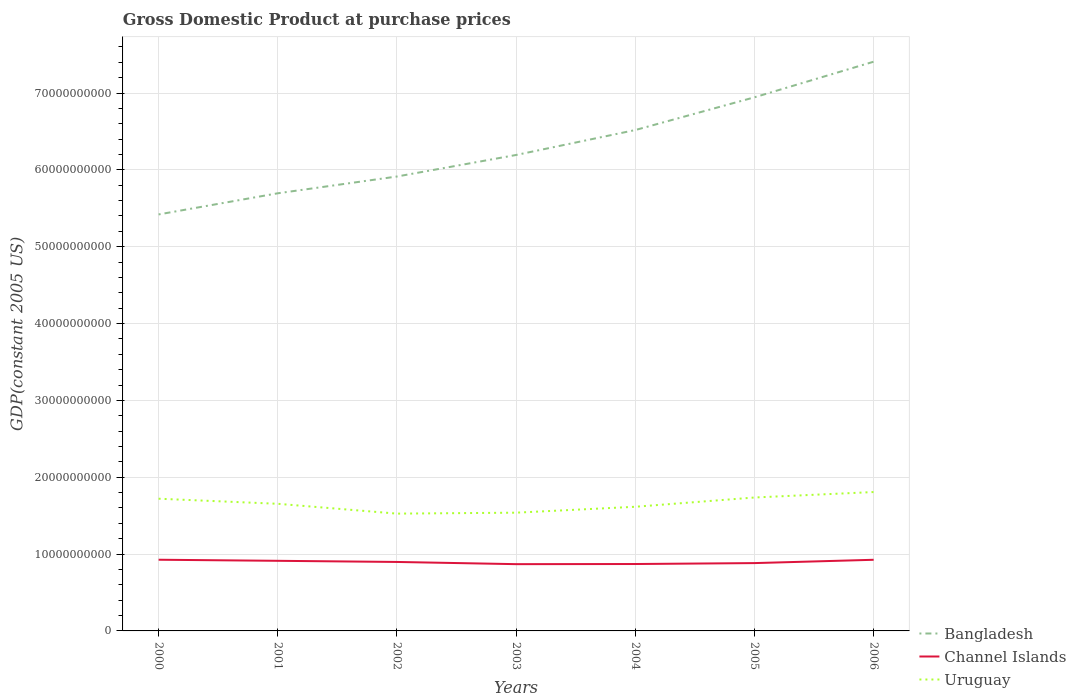Does the line corresponding to Channel Islands intersect with the line corresponding to Bangladesh?
Provide a succinct answer. No. Is the number of lines equal to the number of legend labels?
Your response must be concise. Yes. Across all years, what is the maximum GDP at purchase prices in Channel Islands?
Offer a very short reply. 8.69e+09. What is the total GDP at purchase prices in Channel Islands in the graph?
Give a very brief answer. 6.08e+06. What is the difference between the highest and the second highest GDP at purchase prices in Uruguay?
Make the answer very short. 2.81e+09. What is the difference between the highest and the lowest GDP at purchase prices in Channel Islands?
Give a very brief answer. 3. How many lines are there?
Provide a succinct answer. 3. How many years are there in the graph?
Offer a terse response. 7. Are the values on the major ticks of Y-axis written in scientific E-notation?
Provide a short and direct response. No. Does the graph contain any zero values?
Make the answer very short. No. Does the graph contain grids?
Keep it short and to the point. Yes. Where does the legend appear in the graph?
Provide a short and direct response. Bottom right. How many legend labels are there?
Provide a short and direct response. 3. How are the legend labels stacked?
Provide a short and direct response. Vertical. What is the title of the graph?
Your answer should be compact. Gross Domestic Product at purchase prices. Does "French Polynesia" appear as one of the legend labels in the graph?
Give a very brief answer. No. What is the label or title of the X-axis?
Keep it short and to the point. Years. What is the label or title of the Y-axis?
Provide a short and direct response. GDP(constant 2005 US). What is the GDP(constant 2005 US) of Bangladesh in 2000?
Provide a short and direct response. 5.42e+1. What is the GDP(constant 2005 US) in Channel Islands in 2000?
Your answer should be compact. 9.26e+09. What is the GDP(constant 2005 US) in Uruguay in 2000?
Your answer should be very brief. 1.72e+1. What is the GDP(constant 2005 US) of Bangladesh in 2001?
Keep it short and to the point. 5.70e+1. What is the GDP(constant 2005 US) of Channel Islands in 2001?
Provide a succinct answer. 9.12e+09. What is the GDP(constant 2005 US) in Uruguay in 2001?
Offer a terse response. 1.65e+1. What is the GDP(constant 2005 US) of Bangladesh in 2002?
Offer a terse response. 5.91e+1. What is the GDP(constant 2005 US) in Channel Islands in 2002?
Make the answer very short. 8.98e+09. What is the GDP(constant 2005 US) in Uruguay in 2002?
Keep it short and to the point. 1.53e+1. What is the GDP(constant 2005 US) of Bangladesh in 2003?
Your response must be concise. 6.19e+1. What is the GDP(constant 2005 US) of Channel Islands in 2003?
Give a very brief answer. 8.69e+09. What is the GDP(constant 2005 US) of Uruguay in 2003?
Provide a short and direct response. 1.54e+1. What is the GDP(constant 2005 US) of Bangladesh in 2004?
Keep it short and to the point. 6.52e+1. What is the GDP(constant 2005 US) of Channel Islands in 2004?
Give a very brief answer. 8.71e+09. What is the GDP(constant 2005 US) of Uruguay in 2004?
Your answer should be very brief. 1.62e+1. What is the GDP(constant 2005 US) in Bangladesh in 2005?
Ensure brevity in your answer.  6.94e+1. What is the GDP(constant 2005 US) in Channel Islands in 2005?
Make the answer very short. 8.83e+09. What is the GDP(constant 2005 US) in Uruguay in 2005?
Offer a terse response. 1.74e+1. What is the GDP(constant 2005 US) of Bangladesh in 2006?
Offer a terse response. 7.41e+1. What is the GDP(constant 2005 US) of Channel Islands in 2006?
Offer a terse response. 9.26e+09. What is the GDP(constant 2005 US) in Uruguay in 2006?
Your answer should be compact. 1.81e+1. Across all years, what is the maximum GDP(constant 2005 US) of Bangladesh?
Give a very brief answer. 7.41e+1. Across all years, what is the maximum GDP(constant 2005 US) in Channel Islands?
Ensure brevity in your answer.  9.26e+09. Across all years, what is the maximum GDP(constant 2005 US) of Uruguay?
Ensure brevity in your answer.  1.81e+1. Across all years, what is the minimum GDP(constant 2005 US) of Bangladesh?
Offer a very short reply. 5.42e+1. Across all years, what is the minimum GDP(constant 2005 US) in Channel Islands?
Your response must be concise. 8.69e+09. Across all years, what is the minimum GDP(constant 2005 US) of Uruguay?
Provide a succinct answer. 1.53e+1. What is the total GDP(constant 2005 US) of Bangladesh in the graph?
Offer a terse response. 4.41e+11. What is the total GDP(constant 2005 US) in Channel Islands in the graph?
Your answer should be compact. 6.28e+1. What is the total GDP(constant 2005 US) in Uruguay in the graph?
Your response must be concise. 1.16e+11. What is the difference between the GDP(constant 2005 US) in Bangladesh in 2000 and that in 2001?
Provide a succinct answer. -2.75e+09. What is the difference between the GDP(constant 2005 US) in Channel Islands in 2000 and that in 2001?
Provide a succinct answer. 1.40e+08. What is the difference between the GDP(constant 2005 US) of Uruguay in 2000 and that in 2001?
Provide a short and direct response. 6.61e+08. What is the difference between the GDP(constant 2005 US) of Bangladesh in 2000 and that in 2002?
Your answer should be very brief. -4.93e+09. What is the difference between the GDP(constant 2005 US) of Channel Islands in 2000 and that in 2002?
Offer a very short reply. 2.89e+08. What is the difference between the GDP(constant 2005 US) in Uruguay in 2000 and that in 2002?
Provide a short and direct response. 1.94e+09. What is the difference between the GDP(constant 2005 US) in Bangladesh in 2000 and that in 2003?
Your response must be concise. -7.74e+09. What is the difference between the GDP(constant 2005 US) of Channel Islands in 2000 and that in 2003?
Offer a very short reply. 5.76e+08. What is the difference between the GDP(constant 2005 US) of Uruguay in 2000 and that in 2003?
Provide a short and direct response. 1.82e+09. What is the difference between the GDP(constant 2005 US) in Bangladesh in 2000 and that in 2004?
Keep it short and to the point. -1.10e+1. What is the difference between the GDP(constant 2005 US) in Channel Islands in 2000 and that in 2004?
Give a very brief answer. 5.57e+08. What is the difference between the GDP(constant 2005 US) in Uruguay in 2000 and that in 2004?
Your response must be concise. 1.05e+09. What is the difference between the GDP(constant 2005 US) of Bangladesh in 2000 and that in 2005?
Keep it short and to the point. -1.52e+1. What is the difference between the GDP(constant 2005 US) of Channel Islands in 2000 and that in 2005?
Your response must be concise. 4.37e+08. What is the difference between the GDP(constant 2005 US) in Uruguay in 2000 and that in 2005?
Offer a very short reply. -1.58e+08. What is the difference between the GDP(constant 2005 US) of Bangladesh in 2000 and that in 2006?
Offer a terse response. -1.99e+1. What is the difference between the GDP(constant 2005 US) of Channel Islands in 2000 and that in 2006?
Give a very brief answer. 6.08e+06. What is the difference between the GDP(constant 2005 US) in Uruguay in 2000 and that in 2006?
Make the answer very short. -8.69e+08. What is the difference between the GDP(constant 2005 US) in Bangladesh in 2001 and that in 2002?
Offer a very short reply. -2.18e+09. What is the difference between the GDP(constant 2005 US) in Channel Islands in 2001 and that in 2002?
Your answer should be very brief. 1.49e+08. What is the difference between the GDP(constant 2005 US) in Uruguay in 2001 and that in 2002?
Provide a short and direct response. 1.28e+09. What is the difference between the GDP(constant 2005 US) in Bangladesh in 2001 and that in 2003?
Ensure brevity in your answer.  -4.99e+09. What is the difference between the GDP(constant 2005 US) of Channel Islands in 2001 and that in 2003?
Your response must be concise. 4.36e+08. What is the difference between the GDP(constant 2005 US) of Uruguay in 2001 and that in 2003?
Keep it short and to the point. 1.16e+09. What is the difference between the GDP(constant 2005 US) of Bangladesh in 2001 and that in 2004?
Make the answer very short. -8.23e+09. What is the difference between the GDP(constant 2005 US) of Channel Islands in 2001 and that in 2004?
Ensure brevity in your answer.  4.17e+08. What is the difference between the GDP(constant 2005 US) in Uruguay in 2001 and that in 2004?
Offer a terse response. 3.86e+08. What is the difference between the GDP(constant 2005 US) in Bangladesh in 2001 and that in 2005?
Make the answer very short. -1.25e+1. What is the difference between the GDP(constant 2005 US) in Channel Islands in 2001 and that in 2005?
Give a very brief answer. 2.97e+08. What is the difference between the GDP(constant 2005 US) in Uruguay in 2001 and that in 2005?
Give a very brief answer. -8.19e+08. What is the difference between the GDP(constant 2005 US) of Bangladesh in 2001 and that in 2006?
Offer a terse response. -1.71e+1. What is the difference between the GDP(constant 2005 US) of Channel Islands in 2001 and that in 2006?
Your answer should be compact. -1.34e+08. What is the difference between the GDP(constant 2005 US) of Uruguay in 2001 and that in 2006?
Ensure brevity in your answer.  -1.53e+09. What is the difference between the GDP(constant 2005 US) of Bangladesh in 2002 and that in 2003?
Provide a short and direct response. -2.80e+09. What is the difference between the GDP(constant 2005 US) of Channel Islands in 2002 and that in 2003?
Keep it short and to the point. 2.87e+08. What is the difference between the GDP(constant 2005 US) of Uruguay in 2002 and that in 2003?
Offer a terse response. -1.23e+08. What is the difference between the GDP(constant 2005 US) in Bangladesh in 2002 and that in 2004?
Provide a succinct answer. -6.05e+09. What is the difference between the GDP(constant 2005 US) in Channel Islands in 2002 and that in 2004?
Make the answer very short. 2.68e+08. What is the difference between the GDP(constant 2005 US) of Uruguay in 2002 and that in 2004?
Offer a very short reply. -8.93e+08. What is the difference between the GDP(constant 2005 US) of Bangladesh in 2002 and that in 2005?
Offer a terse response. -1.03e+1. What is the difference between the GDP(constant 2005 US) in Channel Islands in 2002 and that in 2005?
Provide a succinct answer. 1.48e+08. What is the difference between the GDP(constant 2005 US) of Uruguay in 2002 and that in 2005?
Offer a terse response. -2.10e+09. What is the difference between the GDP(constant 2005 US) of Bangladesh in 2002 and that in 2006?
Make the answer very short. -1.49e+1. What is the difference between the GDP(constant 2005 US) of Channel Islands in 2002 and that in 2006?
Provide a succinct answer. -2.83e+08. What is the difference between the GDP(constant 2005 US) of Uruguay in 2002 and that in 2006?
Offer a very short reply. -2.81e+09. What is the difference between the GDP(constant 2005 US) of Bangladesh in 2003 and that in 2004?
Your response must be concise. -3.25e+09. What is the difference between the GDP(constant 2005 US) of Channel Islands in 2003 and that in 2004?
Provide a short and direct response. -1.95e+07. What is the difference between the GDP(constant 2005 US) in Uruguay in 2003 and that in 2004?
Ensure brevity in your answer.  -7.70e+08. What is the difference between the GDP(constant 2005 US) of Bangladesh in 2003 and that in 2005?
Provide a succinct answer. -7.51e+09. What is the difference between the GDP(constant 2005 US) in Channel Islands in 2003 and that in 2005?
Give a very brief answer. -1.39e+08. What is the difference between the GDP(constant 2005 US) of Uruguay in 2003 and that in 2005?
Offer a very short reply. -1.98e+09. What is the difference between the GDP(constant 2005 US) of Bangladesh in 2003 and that in 2006?
Your response must be concise. -1.21e+1. What is the difference between the GDP(constant 2005 US) of Channel Islands in 2003 and that in 2006?
Offer a very short reply. -5.70e+08. What is the difference between the GDP(constant 2005 US) in Uruguay in 2003 and that in 2006?
Keep it short and to the point. -2.69e+09. What is the difference between the GDP(constant 2005 US) in Bangladesh in 2004 and that in 2005?
Ensure brevity in your answer.  -4.26e+09. What is the difference between the GDP(constant 2005 US) in Channel Islands in 2004 and that in 2005?
Your answer should be compact. -1.20e+08. What is the difference between the GDP(constant 2005 US) in Uruguay in 2004 and that in 2005?
Ensure brevity in your answer.  -1.21e+09. What is the difference between the GDP(constant 2005 US) in Bangladesh in 2004 and that in 2006?
Provide a succinct answer. -8.89e+09. What is the difference between the GDP(constant 2005 US) in Channel Islands in 2004 and that in 2006?
Offer a very short reply. -5.51e+08. What is the difference between the GDP(constant 2005 US) of Uruguay in 2004 and that in 2006?
Provide a succinct answer. -1.92e+09. What is the difference between the GDP(constant 2005 US) of Bangladesh in 2005 and that in 2006?
Offer a very short reply. -4.63e+09. What is the difference between the GDP(constant 2005 US) in Channel Islands in 2005 and that in 2006?
Provide a short and direct response. -4.31e+08. What is the difference between the GDP(constant 2005 US) in Uruguay in 2005 and that in 2006?
Make the answer very short. -7.12e+08. What is the difference between the GDP(constant 2005 US) of Bangladesh in 2000 and the GDP(constant 2005 US) of Channel Islands in 2001?
Keep it short and to the point. 4.51e+1. What is the difference between the GDP(constant 2005 US) of Bangladesh in 2000 and the GDP(constant 2005 US) of Uruguay in 2001?
Make the answer very short. 3.77e+1. What is the difference between the GDP(constant 2005 US) in Channel Islands in 2000 and the GDP(constant 2005 US) in Uruguay in 2001?
Provide a succinct answer. -7.28e+09. What is the difference between the GDP(constant 2005 US) in Bangladesh in 2000 and the GDP(constant 2005 US) in Channel Islands in 2002?
Provide a succinct answer. 4.52e+1. What is the difference between the GDP(constant 2005 US) in Bangladesh in 2000 and the GDP(constant 2005 US) in Uruguay in 2002?
Give a very brief answer. 3.89e+1. What is the difference between the GDP(constant 2005 US) of Channel Islands in 2000 and the GDP(constant 2005 US) of Uruguay in 2002?
Make the answer very short. -6.00e+09. What is the difference between the GDP(constant 2005 US) of Bangladesh in 2000 and the GDP(constant 2005 US) of Channel Islands in 2003?
Give a very brief answer. 4.55e+1. What is the difference between the GDP(constant 2005 US) in Bangladesh in 2000 and the GDP(constant 2005 US) in Uruguay in 2003?
Offer a very short reply. 3.88e+1. What is the difference between the GDP(constant 2005 US) in Channel Islands in 2000 and the GDP(constant 2005 US) in Uruguay in 2003?
Offer a terse response. -6.12e+09. What is the difference between the GDP(constant 2005 US) in Bangladesh in 2000 and the GDP(constant 2005 US) in Channel Islands in 2004?
Provide a succinct answer. 4.55e+1. What is the difference between the GDP(constant 2005 US) of Bangladesh in 2000 and the GDP(constant 2005 US) of Uruguay in 2004?
Provide a succinct answer. 3.80e+1. What is the difference between the GDP(constant 2005 US) of Channel Islands in 2000 and the GDP(constant 2005 US) of Uruguay in 2004?
Give a very brief answer. -6.89e+09. What is the difference between the GDP(constant 2005 US) in Bangladesh in 2000 and the GDP(constant 2005 US) in Channel Islands in 2005?
Give a very brief answer. 4.54e+1. What is the difference between the GDP(constant 2005 US) of Bangladesh in 2000 and the GDP(constant 2005 US) of Uruguay in 2005?
Your answer should be compact. 3.68e+1. What is the difference between the GDP(constant 2005 US) in Channel Islands in 2000 and the GDP(constant 2005 US) in Uruguay in 2005?
Ensure brevity in your answer.  -8.10e+09. What is the difference between the GDP(constant 2005 US) in Bangladesh in 2000 and the GDP(constant 2005 US) in Channel Islands in 2006?
Provide a succinct answer. 4.49e+1. What is the difference between the GDP(constant 2005 US) of Bangladesh in 2000 and the GDP(constant 2005 US) of Uruguay in 2006?
Offer a terse response. 3.61e+1. What is the difference between the GDP(constant 2005 US) in Channel Islands in 2000 and the GDP(constant 2005 US) in Uruguay in 2006?
Your answer should be very brief. -8.81e+09. What is the difference between the GDP(constant 2005 US) of Bangladesh in 2001 and the GDP(constant 2005 US) of Channel Islands in 2002?
Offer a terse response. 4.80e+1. What is the difference between the GDP(constant 2005 US) in Bangladesh in 2001 and the GDP(constant 2005 US) in Uruguay in 2002?
Provide a succinct answer. 4.17e+1. What is the difference between the GDP(constant 2005 US) of Channel Islands in 2001 and the GDP(constant 2005 US) of Uruguay in 2002?
Your answer should be compact. -6.14e+09. What is the difference between the GDP(constant 2005 US) of Bangladesh in 2001 and the GDP(constant 2005 US) of Channel Islands in 2003?
Offer a terse response. 4.83e+1. What is the difference between the GDP(constant 2005 US) in Bangladesh in 2001 and the GDP(constant 2005 US) in Uruguay in 2003?
Your answer should be compact. 4.16e+1. What is the difference between the GDP(constant 2005 US) in Channel Islands in 2001 and the GDP(constant 2005 US) in Uruguay in 2003?
Provide a succinct answer. -6.26e+09. What is the difference between the GDP(constant 2005 US) of Bangladesh in 2001 and the GDP(constant 2005 US) of Channel Islands in 2004?
Your response must be concise. 4.82e+1. What is the difference between the GDP(constant 2005 US) in Bangladesh in 2001 and the GDP(constant 2005 US) in Uruguay in 2004?
Your answer should be very brief. 4.08e+1. What is the difference between the GDP(constant 2005 US) of Channel Islands in 2001 and the GDP(constant 2005 US) of Uruguay in 2004?
Your response must be concise. -7.03e+09. What is the difference between the GDP(constant 2005 US) of Bangladesh in 2001 and the GDP(constant 2005 US) of Channel Islands in 2005?
Offer a terse response. 4.81e+1. What is the difference between the GDP(constant 2005 US) in Bangladesh in 2001 and the GDP(constant 2005 US) in Uruguay in 2005?
Provide a short and direct response. 3.96e+1. What is the difference between the GDP(constant 2005 US) in Channel Islands in 2001 and the GDP(constant 2005 US) in Uruguay in 2005?
Ensure brevity in your answer.  -8.24e+09. What is the difference between the GDP(constant 2005 US) in Bangladesh in 2001 and the GDP(constant 2005 US) in Channel Islands in 2006?
Offer a terse response. 4.77e+1. What is the difference between the GDP(constant 2005 US) of Bangladesh in 2001 and the GDP(constant 2005 US) of Uruguay in 2006?
Keep it short and to the point. 3.89e+1. What is the difference between the GDP(constant 2005 US) in Channel Islands in 2001 and the GDP(constant 2005 US) in Uruguay in 2006?
Keep it short and to the point. -8.95e+09. What is the difference between the GDP(constant 2005 US) of Bangladesh in 2002 and the GDP(constant 2005 US) of Channel Islands in 2003?
Offer a very short reply. 5.04e+1. What is the difference between the GDP(constant 2005 US) of Bangladesh in 2002 and the GDP(constant 2005 US) of Uruguay in 2003?
Ensure brevity in your answer.  4.37e+1. What is the difference between the GDP(constant 2005 US) in Channel Islands in 2002 and the GDP(constant 2005 US) in Uruguay in 2003?
Give a very brief answer. -6.41e+09. What is the difference between the GDP(constant 2005 US) of Bangladesh in 2002 and the GDP(constant 2005 US) of Channel Islands in 2004?
Your answer should be very brief. 5.04e+1. What is the difference between the GDP(constant 2005 US) in Bangladesh in 2002 and the GDP(constant 2005 US) in Uruguay in 2004?
Ensure brevity in your answer.  4.30e+1. What is the difference between the GDP(constant 2005 US) in Channel Islands in 2002 and the GDP(constant 2005 US) in Uruguay in 2004?
Give a very brief answer. -7.18e+09. What is the difference between the GDP(constant 2005 US) of Bangladesh in 2002 and the GDP(constant 2005 US) of Channel Islands in 2005?
Your answer should be very brief. 5.03e+1. What is the difference between the GDP(constant 2005 US) of Bangladesh in 2002 and the GDP(constant 2005 US) of Uruguay in 2005?
Provide a short and direct response. 4.18e+1. What is the difference between the GDP(constant 2005 US) of Channel Islands in 2002 and the GDP(constant 2005 US) of Uruguay in 2005?
Keep it short and to the point. -8.39e+09. What is the difference between the GDP(constant 2005 US) in Bangladesh in 2002 and the GDP(constant 2005 US) in Channel Islands in 2006?
Ensure brevity in your answer.  4.99e+1. What is the difference between the GDP(constant 2005 US) in Bangladesh in 2002 and the GDP(constant 2005 US) in Uruguay in 2006?
Provide a short and direct response. 4.11e+1. What is the difference between the GDP(constant 2005 US) of Channel Islands in 2002 and the GDP(constant 2005 US) of Uruguay in 2006?
Ensure brevity in your answer.  -9.10e+09. What is the difference between the GDP(constant 2005 US) of Bangladesh in 2003 and the GDP(constant 2005 US) of Channel Islands in 2004?
Give a very brief answer. 5.32e+1. What is the difference between the GDP(constant 2005 US) in Bangladesh in 2003 and the GDP(constant 2005 US) in Uruguay in 2004?
Give a very brief answer. 4.58e+1. What is the difference between the GDP(constant 2005 US) in Channel Islands in 2003 and the GDP(constant 2005 US) in Uruguay in 2004?
Ensure brevity in your answer.  -7.47e+09. What is the difference between the GDP(constant 2005 US) in Bangladesh in 2003 and the GDP(constant 2005 US) in Channel Islands in 2005?
Offer a very short reply. 5.31e+1. What is the difference between the GDP(constant 2005 US) of Bangladesh in 2003 and the GDP(constant 2005 US) of Uruguay in 2005?
Keep it short and to the point. 4.46e+1. What is the difference between the GDP(constant 2005 US) of Channel Islands in 2003 and the GDP(constant 2005 US) of Uruguay in 2005?
Your response must be concise. -8.68e+09. What is the difference between the GDP(constant 2005 US) of Bangladesh in 2003 and the GDP(constant 2005 US) of Channel Islands in 2006?
Your response must be concise. 5.27e+1. What is the difference between the GDP(constant 2005 US) of Bangladesh in 2003 and the GDP(constant 2005 US) of Uruguay in 2006?
Offer a terse response. 4.39e+1. What is the difference between the GDP(constant 2005 US) in Channel Islands in 2003 and the GDP(constant 2005 US) in Uruguay in 2006?
Ensure brevity in your answer.  -9.39e+09. What is the difference between the GDP(constant 2005 US) of Bangladesh in 2004 and the GDP(constant 2005 US) of Channel Islands in 2005?
Ensure brevity in your answer.  5.64e+1. What is the difference between the GDP(constant 2005 US) in Bangladesh in 2004 and the GDP(constant 2005 US) in Uruguay in 2005?
Make the answer very short. 4.78e+1. What is the difference between the GDP(constant 2005 US) of Channel Islands in 2004 and the GDP(constant 2005 US) of Uruguay in 2005?
Give a very brief answer. -8.66e+09. What is the difference between the GDP(constant 2005 US) of Bangladesh in 2004 and the GDP(constant 2005 US) of Channel Islands in 2006?
Provide a short and direct response. 5.59e+1. What is the difference between the GDP(constant 2005 US) of Bangladesh in 2004 and the GDP(constant 2005 US) of Uruguay in 2006?
Keep it short and to the point. 4.71e+1. What is the difference between the GDP(constant 2005 US) in Channel Islands in 2004 and the GDP(constant 2005 US) in Uruguay in 2006?
Ensure brevity in your answer.  -9.37e+09. What is the difference between the GDP(constant 2005 US) of Bangladesh in 2005 and the GDP(constant 2005 US) of Channel Islands in 2006?
Provide a short and direct response. 6.02e+1. What is the difference between the GDP(constant 2005 US) of Bangladesh in 2005 and the GDP(constant 2005 US) of Uruguay in 2006?
Keep it short and to the point. 5.14e+1. What is the difference between the GDP(constant 2005 US) in Channel Islands in 2005 and the GDP(constant 2005 US) in Uruguay in 2006?
Ensure brevity in your answer.  -9.25e+09. What is the average GDP(constant 2005 US) of Bangladesh per year?
Provide a succinct answer. 6.30e+1. What is the average GDP(constant 2005 US) in Channel Islands per year?
Offer a very short reply. 8.98e+09. What is the average GDP(constant 2005 US) in Uruguay per year?
Ensure brevity in your answer.  1.66e+1. In the year 2000, what is the difference between the GDP(constant 2005 US) of Bangladesh and GDP(constant 2005 US) of Channel Islands?
Offer a terse response. 4.49e+1. In the year 2000, what is the difference between the GDP(constant 2005 US) in Bangladesh and GDP(constant 2005 US) in Uruguay?
Provide a succinct answer. 3.70e+1. In the year 2000, what is the difference between the GDP(constant 2005 US) in Channel Islands and GDP(constant 2005 US) in Uruguay?
Give a very brief answer. -7.94e+09. In the year 2001, what is the difference between the GDP(constant 2005 US) of Bangladesh and GDP(constant 2005 US) of Channel Islands?
Offer a very short reply. 4.78e+1. In the year 2001, what is the difference between the GDP(constant 2005 US) of Bangladesh and GDP(constant 2005 US) of Uruguay?
Your answer should be very brief. 4.04e+1. In the year 2001, what is the difference between the GDP(constant 2005 US) of Channel Islands and GDP(constant 2005 US) of Uruguay?
Your answer should be very brief. -7.42e+09. In the year 2002, what is the difference between the GDP(constant 2005 US) of Bangladesh and GDP(constant 2005 US) of Channel Islands?
Give a very brief answer. 5.02e+1. In the year 2002, what is the difference between the GDP(constant 2005 US) in Bangladesh and GDP(constant 2005 US) in Uruguay?
Your response must be concise. 4.39e+1. In the year 2002, what is the difference between the GDP(constant 2005 US) of Channel Islands and GDP(constant 2005 US) of Uruguay?
Your answer should be compact. -6.29e+09. In the year 2003, what is the difference between the GDP(constant 2005 US) of Bangladesh and GDP(constant 2005 US) of Channel Islands?
Your answer should be very brief. 5.32e+1. In the year 2003, what is the difference between the GDP(constant 2005 US) of Bangladesh and GDP(constant 2005 US) of Uruguay?
Offer a terse response. 4.65e+1. In the year 2003, what is the difference between the GDP(constant 2005 US) in Channel Islands and GDP(constant 2005 US) in Uruguay?
Offer a terse response. -6.70e+09. In the year 2004, what is the difference between the GDP(constant 2005 US) of Bangladesh and GDP(constant 2005 US) of Channel Islands?
Offer a terse response. 5.65e+1. In the year 2004, what is the difference between the GDP(constant 2005 US) of Bangladesh and GDP(constant 2005 US) of Uruguay?
Keep it short and to the point. 4.90e+1. In the year 2004, what is the difference between the GDP(constant 2005 US) of Channel Islands and GDP(constant 2005 US) of Uruguay?
Ensure brevity in your answer.  -7.45e+09. In the year 2005, what is the difference between the GDP(constant 2005 US) in Bangladesh and GDP(constant 2005 US) in Channel Islands?
Ensure brevity in your answer.  6.06e+1. In the year 2005, what is the difference between the GDP(constant 2005 US) in Bangladesh and GDP(constant 2005 US) in Uruguay?
Your response must be concise. 5.21e+1. In the year 2005, what is the difference between the GDP(constant 2005 US) of Channel Islands and GDP(constant 2005 US) of Uruguay?
Your answer should be very brief. -8.54e+09. In the year 2006, what is the difference between the GDP(constant 2005 US) in Bangladesh and GDP(constant 2005 US) in Channel Islands?
Your response must be concise. 6.48e+1. In the year 2006, what is the difference between the GDP(constant 2005 US) in Bangladesh and GDP(constant 2005 US) in Uruguay?
Ensure brevity in your answer.  5.60e+1. In the year 2006, what is the difference between the GDP(constant 2005 US) of Channel Islands and GDP(constant 2005 US) of Uruguay?
Provide a short and direct response. -8.82e+09. What is the ratio of the GDP(constant 2005 US) in Bangladesh in 2000 to that in 2001?
Your answer should be very brief. 0.95. What is the ratio of the GDP(constant 2005 US) of Channel Islands in 2000 to that in 2001?
Provide a short and direct response. 1.02. What is the ratio of the GDP(constant 2005 US) in Uruguay in 2000 to that in 2001?
Make the answer very short. 1.04. What is the ratio of the GDP(constant 2005 US) of Bangladesh in 2000 to that in 2002?
Provide a short and direct response. 0.92. What is the ratio of the GDP(constant 2005 US) of Channel Islands in 2000 to that in 2002?
Offer a very short reply. 1.03. What is the ratio of the GDP(constant 2005 US) of Uruguay in 2000 to that in 2002?
Give a very brief answer. 1.13. What is the ratio of the GDP(constant 2005 US) of Bangladesh in 2000 to that in 2003?
Offer a very short reply. 0.88. What is the ratio of the GDP(constant 2005 US) of Channel Islands in 2000 to that in 2003?
Ensure brevity in your answer.  1.07. What is the ratio of the GDP(constant 2005 US) in Uruguay in 2000 to that in 2003?
Provide a short and direct response. 1.12. What is the ratio of the GDP(constant 2005 US) in Bangladesh in 2000 to that in 2004?
Provide a succinct answer. 0.83. What is the ratio of the GDP(constant 2005 US) in Channel Islands in 2000 to that in 2004?
Offer a very short reply. 1.06. What is the ratio of the GDP(constant 2005 US) of Uruguay in 2000 to that in 2004?
Offer a terse response. 1.06. What is the ratio of the GDP(constant 2005 US) of Bangladesh in 2000 to that in 2005?
Provide a succinct answer. 0.78. What is the ratio of the GDP(constant 2005 US) in Channel Islands in 2000 to that in 2005?
Keep it short and to the point. 1.05. What is the ratio of the GDP(constant 2005 US) in Uruguay in 2000 to that in 2005?
Offer a very short reply. 0.99. What is the ratio of the GDP(constant 2005 US) of Bangladesh in 2000 to that in 2006?
Your response must be concise. 0.73. What is the ratio of the GDP(constant 2005 US) of Channel Islands in 2000 to that in 2006?
Keep it short and to the point. 1. What is the ratio of the GDP(constant 2005 US) of Uruguay in 2000 to that in 2006?
Give a very brief answer. 0.95. What is the ratio of the GDP(constant 2005 US) of Bangladesh in 2001 to that in 2002?
Provide a short and direct response. 0.96. What is the ratio of the GDP(constant 2005 US) in Channel Islands in 2001 to that in 2002?
Provide a short and direct response. 1.02. What is the ratio of the GDP(constant 2005 US) in Uruguay in 2001 to that in 2002?
Offer a terse response. 1.08. What is the ratio of the GDP(constant 2005 US) of Bangladesh in 2001 to that in 2003?
Give a very brief answer. 0.92. What is the ratio of the GDP(constant 2005 US) of Channel Islands in 2001 to that in 2003?
Offer a terse response. 1.05. What is the ratio of the GDP(constant 2005 US) of Uruguay in 2001 to that in 2003?
Give a very brief answer. 1.08. What is the ratio of the GDP(constant 2005 US) of Bangladesh in 2001 to that in 2004?
Your answer should be compact. 0.87. What is the ratio of the GDP(constant 2005 US) of Channel Islands in 2001 to that in 2004?
Offer a very short reply. 1.05. What is the ratio of the GDP(constant 2005 US) of Uruguay in 2001 to that in 2004?
Your answer should be compact. 1.02. What is the ratio of the GDP(constant 2005 US) of Bangladesh in 2001 to that in 2005?
Your response must be concise. 0.82. What is the ratio of the GDP(constant 2005 US) of Channel Islands in 2001 to that in 2005?
Keep it short and to the point. 1.03. What is the ratio of the GDP(constant 2005 US) of Uruguay in 2001 to that in 2005?
Your response must be concise. 0.95. What is the ratio of the GDP(constant 2005 US) of Bangladesh in 2001 to that in 2006?
Your answer should be very brief. 0.77. What is the ratio of the GDP(constant 2005 US) of Channel Islands in 2001 to that in 2006?
Ensure brevity in your answer.  0.99. What is the ratio of the GDP(constant 2005 US) of Uruguay in 2001 to that in 2006?
Offer a very short reply. 0.92. What is the ratio of the GDP(constant 2005 US) in Bangladesh in 2002 to that in 2003?
Ensure brevity in your answer.  0.95. What is the ratio of the GDP(constant 2005 US) in Channel Islands in 2002 to that in 2003?
Offer a terse response. 1.03. What is the ratio of the GDP(constant 2005 US) in Uruguay in 2002 to that in 2003?
Your answer should be compact. 0.99. What is the ratio of the GDP(constant 2005 US) of Bangladesh in 2002 to that in 2004?
Offer a terse response. 0.91. What is the ratio of the GDP(constant 2005 US) of Channel Islands in 2002 to that in 2004?
Your response must be concise. 1.03. What is the ratio of the GDP(constant 2005 US) of Uruguay in 2002 to that in 2004?
Your answer should be very brief. 0.94. What is the ratio of the GDP(constant 2005 US) of Bangladesh in 2002 to that in 2005?
Provide a short and direct response. 0.85. What is the ratio of the GDP(constant 2005 US) of Channel Islands in 2002 to that in 2005?
Give a very brief answer. 1.02. What is the ratio of the GDP(constant 2005 US) of Uruguay in 2002 to that in 2005?
Your response must be concise. 0.88. What is the ratio of the GDP(constant 2005 US) of Bangladesh in 2002 to that in 2006?
Offer a terse response. 0.8. What is the ratio of the GDP(constant 2005 US) of Channel Islands in 2002 to that in 2006?
Keep it short and to the point. 0.97. What is the ratio of the GDP(constant 2005 US) in Uruguay in 2002 to that in 2006?
Make the answer very short. 0.84. What is the ratio of the GDP(constant 2005 US) of Bangladesh in 2003 to that in 2004?
Give a very brief answer. 0.95. What is the ratio of the GDP(constant 2005 US) in Uruguay in 2003 to that in 2004?
Your response must be concise. 0.95. What is the ratio of the GDP(constant 2005 US) of Bangladesh in 2003 to that in 2005?
Keep it short and to the point. 0.89. What is the ratio of the GDP(constant 2005 US) in Channel Islands in 2003 to that in 2005?
Provide a succinct answer. 0.98. What is the ratio of the GDP(constant 2005 US) of Uruguay in 2003 to that in 2005?
Offer a very short reply. 0.89. What is the ratio of the GDP(constant 2005 US) of Bangladesh in 2003 to that in 2006?
Offer a terse response. 0.84. What is the ratio of the GDP(constant 2005 US) of Channel Islands in 2003 to that in 2006?
Your answer should be very brief. 0.94. What is the ratio of the GDP(constant 2005 US) of Uruguay in 2003 to that in 2006?
Your response must be concise. 0.85. What is the ratio of the GDP(constant 2005 US) of Bangladesh in 2004 to that in 2005?
Offer a very short reply. 0.94. What is the ratio of the GDP(constant 2005 US) in Channel Islands in 2004 to that in 2005?
Give a very brief answer. 0.99. What is the ratio of the GDP(constant 2005 US) of Uruguay in 2004 to that in 2005?
Provide a short and direct response. 0.93. What is the ratio of the GDP(constant 2005 US) of Bangladesh in 2004 to that in 2006?
Your response must be concise. 0.88. What is the ratio of the GDP(constant 2005 US) in Channel Islands in 2004 to that in 2006?
Ensure brevity in your answer.  0.94. What is the ratio of the GDP(constant 2005 US) in Uruguay in 2004 to that in 2006?
Keep it short and to the point. 0.89. What is the ratio of the GDP(constant 2005 US) of Bangladesh in 2005 to that in 2006?
Your answer should be compact. 0.94. What is the ratio of the GDP(constant 2005 US) in Channel Islands in 2005 to that in 2006?
Your answer should be compact. 0.95. What is the ratio of the GDP(constant 2005 US) of Uruguay in 2005 to that in 2006?
Offer a very short reply. 0.96. What is the difference between the highest and the second highest GDP(constant 2005 US) in Bangladesh?
Provide a succinct answer. 4.63e+09. What is the difference between the highest and the second highest GDP(constant 2005 US) of Channel Islands?
Ensure brevity in your answer.  6.08e+06. What is the difference between the highest and the second highest GDP(constant 2005 US) of Uruguay?
Offer a very short reply. 7.12e+08. What is the difference between the highest and the lowest GDP(constant 2005 US) of Bangladesh?
Your response must be concise. 1.99e+1. What is the difference between the highest and the lowest GDP(constant 2005 US) of Channel Islands?
Ensure brevity in your answer.  5.76e+08. What is the difference between the highest and the lowest GDP(constant 2005 US) of Uruguay?
Provide a succinct answer. 2.81e+09. 